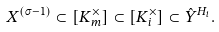Convert formula to latex. <formula><loc_0><loc_0><loc_500><loc_500>X ^ { ( \sigma - 1 ) } \subset [ K _ { m } ^ { \times } ] \subset [ K _ { i } ^ { \times } ] \subset \hat { Y } ^ { H _ { i } } .</formula> 